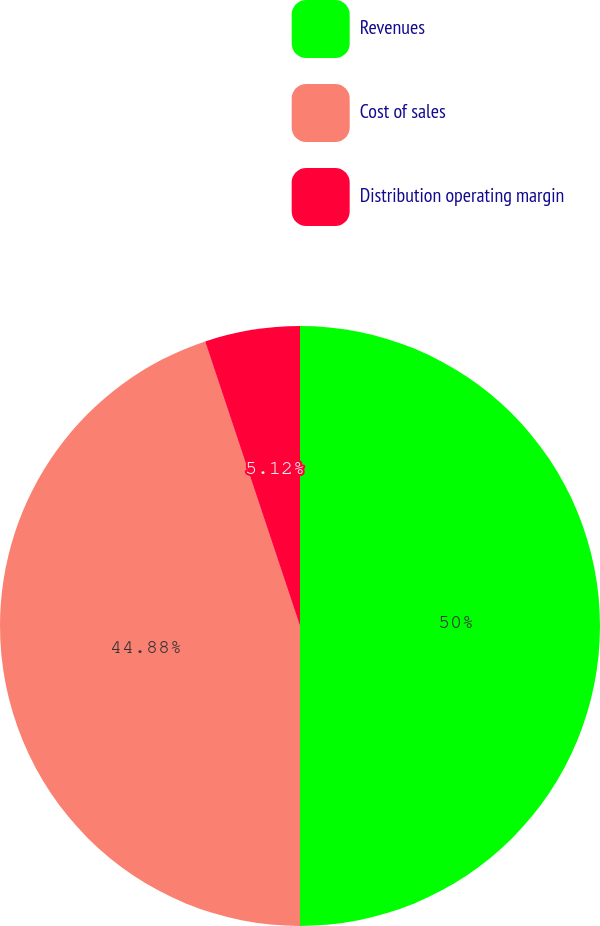Convert chart to OTSL. <chart><loc_0><loc_0><loc_500><loc_500><pie_chart><fcel>Revenues<fcel>Cost of sales<fcel>Distribution operating margin<nl><fcel>50.0%<fcel>44.88%<fcel>5.12%<nl></chart> 